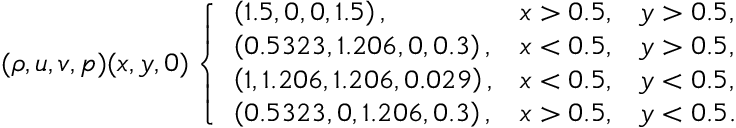<formula> <loc_0><loc_0><loc_500><loc_500>( \rho , u , v , p ) ( x , y , 0 ) \left \{ \begin{array} { l l l } { \left ( 1 . 5 , 0 , 0 , 1 . 5 \right ) , } & { x > 0 . 5 , } & { y > 0 . 5 , } \\ { \left ( 0 . 5 3 2 3 , 1 . 2 0 6 , 0 , 0 . 3 \right ) , } & { x < 0 . 5 , } & { y > 0 . 5 , } \\ { \left ( 1 , 1 . 2 0 6 , 1 . 2 0 6 , 0 . 0 2 9 \right ) , } & { x < 0 . 5 , } & { y < 0 . 5 , } \\ { \left ( 0 . 5 3 2 3 , 0 , 1 . 2 0 6 , 0 . 3 \right ) , } & { x > 0 . 5 , } & { y < 0 . 5 . } \end{array}</formula> 